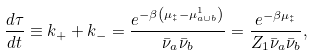Convert formula to latex. <formula><loc_0><loc_0><loc_500><loc_500>\frac { d \tau } { d t } \equiv k _ { + } + k _ { - } = \frac { e ^ { - \beta \left ( { \mu } _ { \ddagger } - { \mu } _ { a \cup b } ^ { 1 } \right ) } } { { \bar { \nu } } _ { a } { \bar { \nu } } _ { b } } = \frac { e ^ { - \beta { \mu } _ { \ddagger } } } { Z _ { 1 } { \bar { \nu } } _ { a } { \bar { \nu } } _ { b } } ,</formula> 